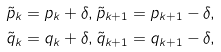Convert formula to latex. <formula><loc_0><loc_0><loc_500><loc_500>\tilde { p } _ { k } = p _ { k } + \delta , \tilde { p } _ { k + 1 } = p _ { k + 1 } - \delta , \\ \tilde { q } _ { k } = q _ { k } + \delta , \tilde { q } _ { k + 1 } = q _ { k + 1 } - \delta ,</formula> 